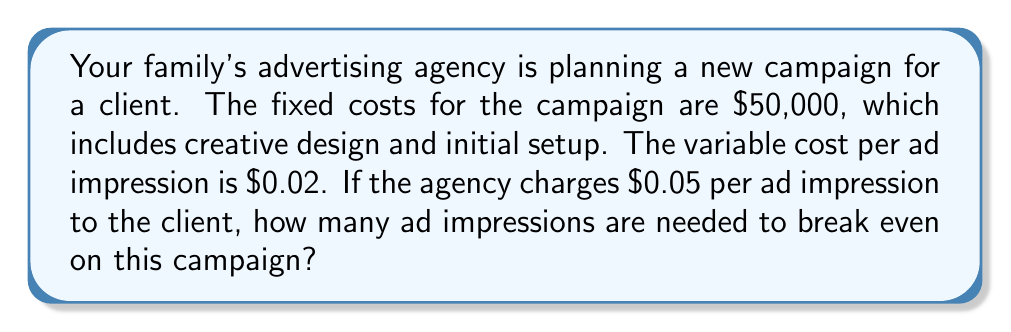Can you answer this question? Let's approach this step-by-step:

1) First, let's define our variables:
   $x$ = number of ad impressions
   $FC$ = Fixed Costs
   $VC$ = Variable Cost per impression
   $P$ = Price charged per impression

2) We know:
   $FC = \$50,000$
   $VC = \$0.02$ per impression
   $P = \$0.05$ per impression

3) At the break-even point, Total Revenue equals Total Costs:
   $TR = TC$

4) We can express this as an equation:
   $Px = FC + VCx$

5) Substituting our known values:
   $0.05x = 50,000 + 0.02x$

6) Simplify by subtracting $0.02x$ from both sides:
   $0.03x = 50,000$

7) Now divide both sides by 0.03:
   $x = \frac{50,000}{0.03} = 1,666,666.67$

8) Since we can't have a fractional impression, we round up to the nearest whole number.
Answer: 1,666,667 ad impressions 